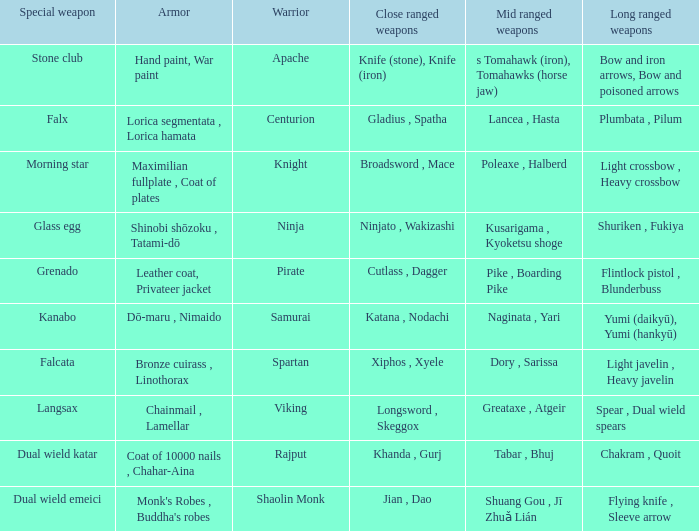Parse the table in full. {'header': ['Special weapon', 'Armor', 'Warrior', 'Close ranged weapons', 'Mid ranged weapons', 'Long ranged weapons'], 'rows': [['Stone club', 'Hand paint, War paint', 'Apache', 'Knife (stone), Knife (iron)', 's Tomahawk (iron), Tomahawks (horse jaw)', 'Bow and iron arrows, Bow and poisoned arrows'], ['Falx', 'Lorica segmentata , Lorica hamata', 'Centurion', 'Gladius , Spatha', 'Lancea , Hasta', 'Plumbata , Pilum'], ['Morning star', 'Maximilian fullplate , Coat of plates', 'Knight', 'Broadsword , Mace', 'Poleaxe , Halberd', 'Light crossbow , Heavy crossbow'], ['Glass egg', 'Shinobi shōzoku , Tatami-dō', 'Ninja', 'Ninjato , Wakizashi', 'Kusarigama , Kyoketsu shoge', 'Shuriken , Fukiya'], ['Grenado', 'Leather coat, Privateer jacket', 'Pirate', 'Cutlass , Dagger', 'Pike , Boarding Pike', 'Flintlock pistol , Blunderbuss'], ['Kanabo', 'Dō-maru , Nimaido', 'Samurai', 'Katana , Nodachi', 'Naginata , Yari', 'Yumi (daikyū), Yumi (hankyū)'], ['Falcata', 'Bronze cuirass , Linothorax', 'Spartan', 'Xiphos , Xyele', 'Dory , Sarissa', 'Light javelin , Heavy javelin'], ['Langsax', 'Chainmail , Lamellar', 'Viking', 'Longsword , Skeggox', 'Greataxe , Atgeir', 'Spear , Dual wield spears'], ['Dual wield katar', 'Coat of 10000 nails , Chahar-Aina', 'Rajput', 'Khanda , Gurj', 'Tabar , Bhuj', 'Chakram , Quoit'], ['Dual wield emeici', "Monk's Robes , Buddha's robes", 'Shaolin Monk', 'Jian , Dao', 'Shuang Gou , Jī Zhuǎ Lián', 'Flying knife , Sleeve arrow']]} If the Close ranged weapons are the knife (stone), knife (iron), what are the Long ranged weapons? Bow and iron arrows, Bow and poisoned arrows. 